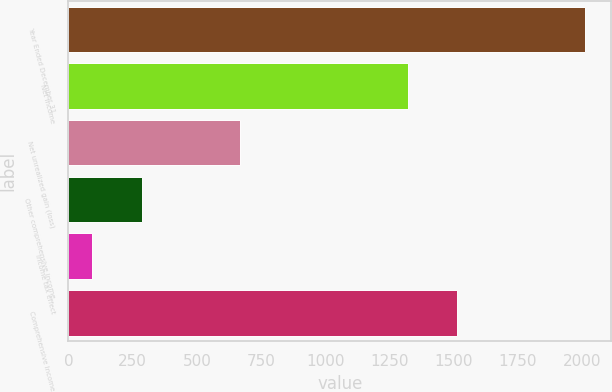Convert chart to OTSL. <chart><loc_0><loc_0><loc_500><loc_500><bar_chart><fcel>Year Ended December 31<fcel>Net income<fcel>Net unrealized gain (loss)<fcel>Other comprehensive income<fcel>Income tax effect<fcel>Comprehensive Income<nl><fcel>2014<fcel>1321<fcel>669.3<fcel>285.1<fcel>93<fcel>1513.1<nl></chart> 